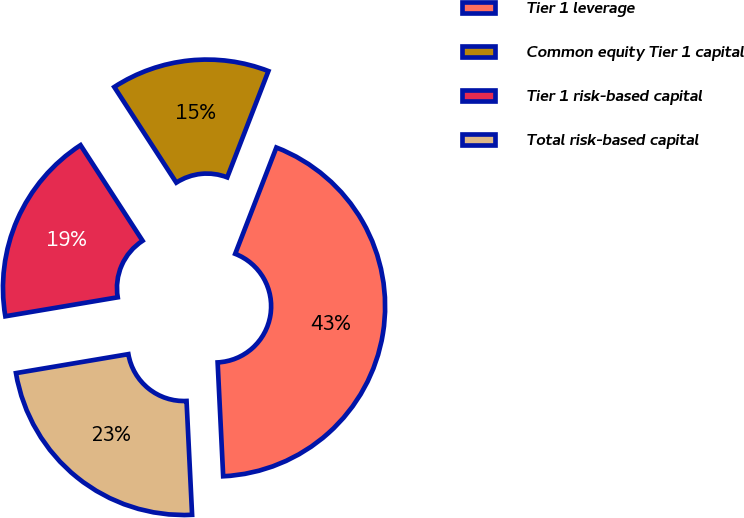<chart> <loc_0><loc_0><loc_500><loc_500><pie_chart><fcel>Tier 1 leverage<fcel>Common equity Tier 1 capital<fcel>Tier 1 risk-based capital<fcel>Total risk-based capital<nl><fcel>43.34%<fcel>15.04%<fcel>18.5%<fcel>23.11%<nl></chart> 